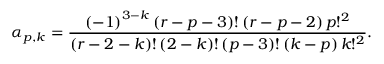<formula> <loc_0><loc_0><loc_500><loc_500>\alpha _ { p , k } = \frac { \left ( - 1 \right ) ^ { 3 - k } \left ( r - p - 3 \right ) ! \left ( r - p - 2 \right ) p ! ^ { 2 } } { \left ( r - 2 - k \right ) ! \left ( 2 - k \right ) ! \left ( p - 3 \right ) ! \left ( k - p \right ) k ! ^ { 2 } } .</formula> 